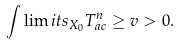Convert formula to latex. <formula><loc_0><loc_0><loc_500><loc_500>\int \lim i t s _ { X _ { 0 } } T _ { a c } ^ { n } \geq v > 0 .</formula> 